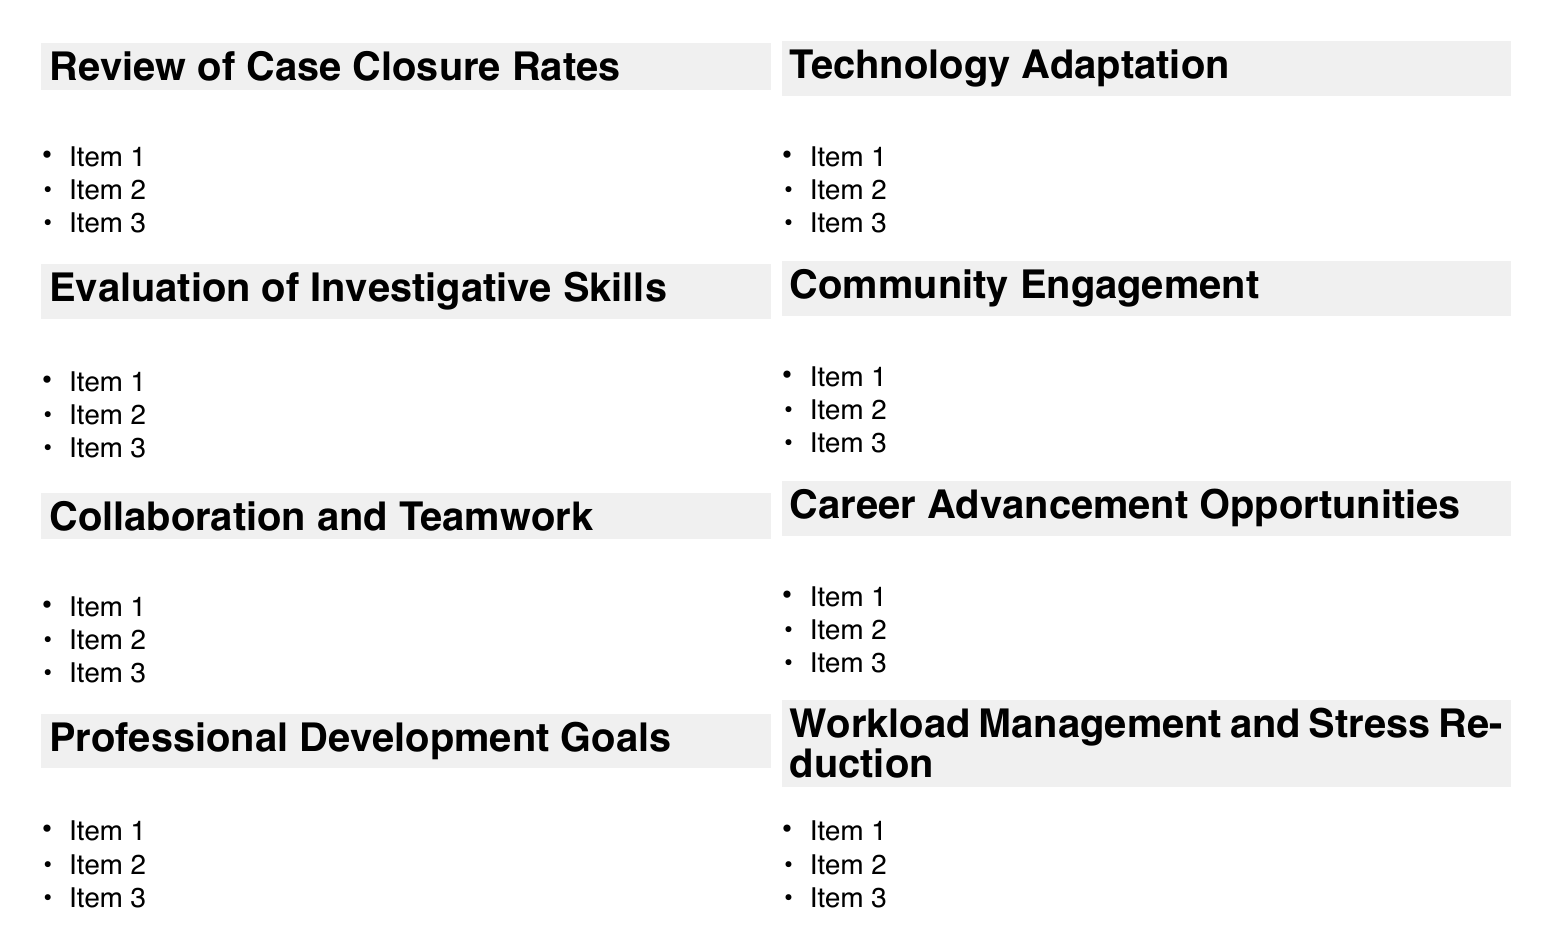What is the first agenda item? The first agenda item is titled "Review of Case Closure Rates."
Answer: Review of Case Closure Rates How many sub-items are listed under "Evaluation of Investigative Skills"? There are four sub-items listed under "Evaluation of Investigative Skills."
Answer: 4 What is one of the professional development goals mentioned? One of the professional development goals is "Advanced training in cybercrime investigation."
Answer: Advanced training in cybercrime investigation What external agency is mentioned in the context of collaboration? The FBI is mentioned as an external agency in the context of collaboration.
Answer: FBI Which technology adaptation tool is related to DNA? CODIS (Combined DNA Index System) is the technology adaptation tool related to DNA.
Answer: CODIS What is the purpose of the "Community Engagement" agenda item? The purpose is to assess the detective's involvement in community-oriented policing efforts.
Answer: Assess involvement in community-oriented policing efforts How many total agenda items are listed? There are a total of eight agenda items listed.
Answer: 8 What potential opportunity is discussed for career advancement? The eligibility for promotion to Sergeant is discussed as a potential opportunity for career advancement.
Answer: Eligibility for promotion to Sergeant 